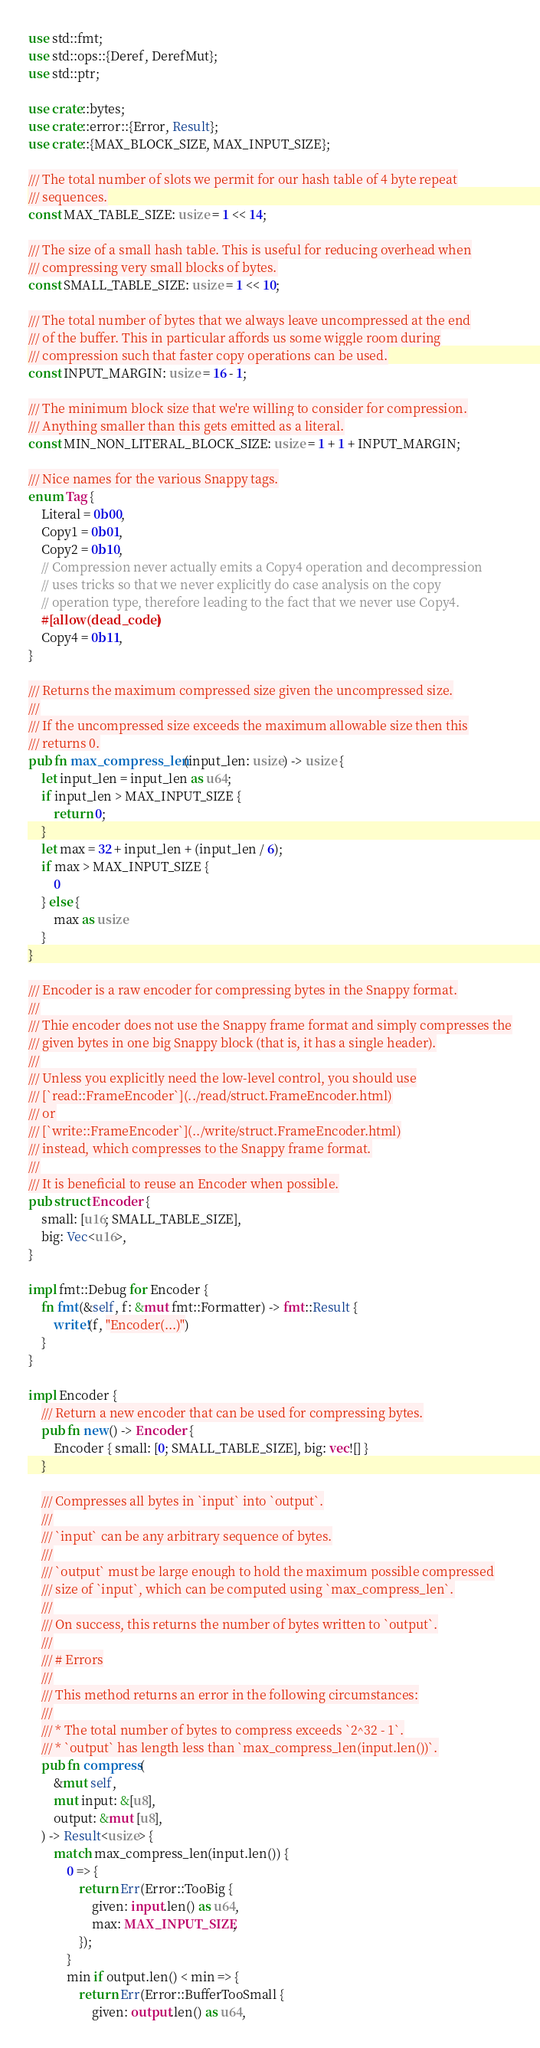<code> <loc_0><loc_0><loc_500><loc_500><_Rust_>use std::fmt;
use std::ops::{Deref, DerefMut};
use std::ptr;

use crate::bytes;
use crate::error::{Error, Result};
use crate::{MAX_BLOCK_SIZE, MAX_INPUT_SIZE};

/// The total number of slots we permit for our hash table of 4 byte repeat
/// sequences.
const MAX_TABLE_SIZE: usize = 1 << 14;

/// The size of a small hash table. This is useful for reducing overhead when
/// compressing very small blocks of bytes.
const SMALL_TABLE_SIZE: usize = 1 << 10;

/// The total number of bytes that we always leave uncompressed at the end
/// of the buffer. This in particular affords us some wiggle room during
/// compression such that faster copy operations can be used.
const INPUT_MARGIN: usize = 16 - 1;

/// The minimum block size that we're willing to consider for compression.
/// Anything smaller than this gets emitted as a literal.
const MIN_NON_LITERAL_BLOCK_SIZE: usize = 1 + 1 + INPUT_MARGIN;

/// Nice names for the various Snappy tags.
enum Tag {
    Literal = 0b00,
    Copy1 = 0b01,
    Copy2 = 0b10,
    // Compression never actually emits a Copy4 operation and decompression
    // uses tricks so that we never explicitly do case analysis on the copy
    // operation type, therefore leading to the fact that we never use Copy4.
    #[allow(dead_code)]
    Copy4 = 0b11,
}

/// Returns the maximum compressed size given the uncompressed size.
///
/// If the uncompressed size exceeds the maximum allowable size then this
/// returns 0.
pub fn max_compress_len(input_len: usize) -> usize {
    let input_len = input_len as u64;
    if input_len > MAX_INPUT_SIZE {
        return 0;
    }
    let max = 32 + input_len + (input_len / 6);
    if max > MAX_INPUT_SIZE {
        0
    } else {
        max as usize
    }
}

/// Encoder is a raw encoder for compressing bytes in the Snappy format.
///
/// Thie encoder does not use the Snappy frame format and simply compresses the
/// given bytes in one big Snappy block (that is, it has a single header).
///
/// Unless you explicitly need the low-level control, you should use
/// [`read::FrameEncoder`](../read/struct.FrameEncoder.html)
/// or
/// [`write::FrameEncoder`](../write/struct.FrameEncoder.html)
/// instead, which compresses to the Snappy frame format.
///
/// It is beneficial to reuse an Encoder when possible.
pub struct Encoder {
    small: [u16; SMALL_TABLE_SIZE],
    big: Vec<u16>,
}

impl fmt::Debug for Encoder {
    fn fmt(&self, f: &mut fmt::Formatter) -> fmt::Result {
        write!(f, "Encoder(...)")
    }
}

impl Encoder {
    /// Return a new encoder that can be used for compressing bytes.
    pub fn new() -> Encoder {
        Encoder { small: [0; SMALL_TABLE_SIZE], big: vec![] }
    }

    /// Compresses all bytes in `input` into `output`.
    ///
    /// `input` can be any arbitrary sequence of bytes.
    ///
    /// `output` must be large enough to hold the maximum possible compressed
    /// size of `input`, which can be computed using `max_compress_len`.
    ///
    /// On success, this returns the number of bytes written to `output`.
    ///
    /// # Errors
    ///
    /// This method returns an error in the following circumstances:
    ///
    /// * The total number of bytes to compress exceeds `2^32 - 1`.
    /// * `output` has length less than `max_compress_len(input.len())`.
    pub fn compress(
        &mut self,
        mut input: &[u8],
        output: &mut [u8],
    ) -> Result<usize> {
        match max_compress_len(input.len()) {
            0 => {
                return Err(Error::TooBig {
                    given: input.len() as u64,
                    max: MAX_INPUT_SIZE,
                });
            }
            min if output.len() < min => {
                return Err(Error::BufferTooSmall {
                    given: output.len() as u64,</code> 